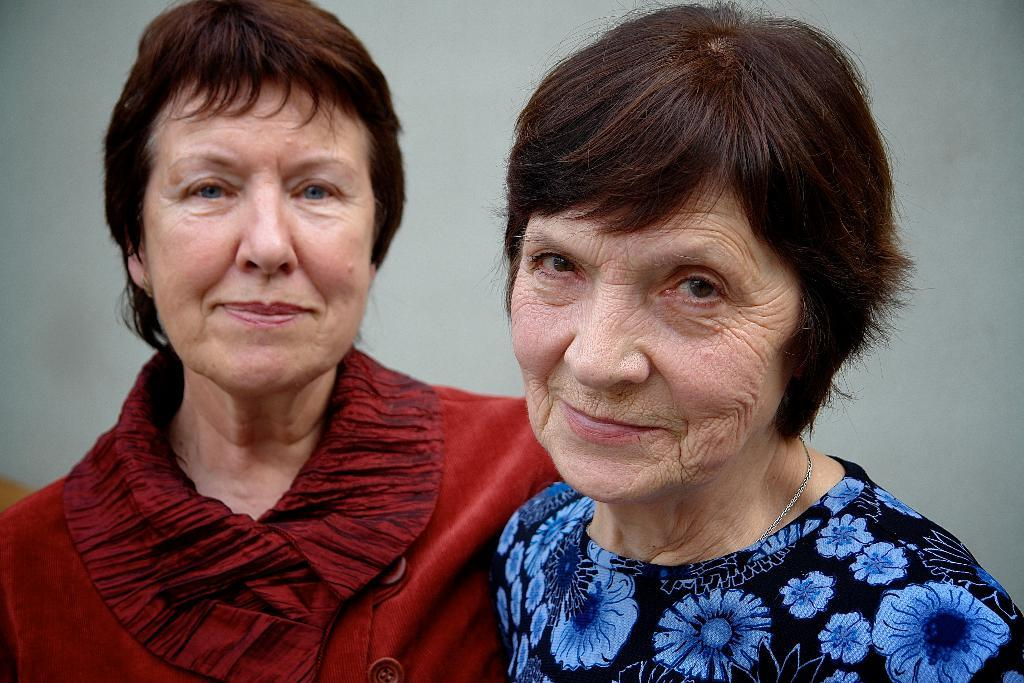How many people are in the image? There are two women in the image. What is the facial expression of the women? The women are smiling. What can be seen in the background of the image? There is a wall in the background of the image. What type of wound can be seen on the woman's arm in the image? There is no wound visible on the women's arms in the image. What color is the powder that the women are holding in the image? There is no powder present in the image. 